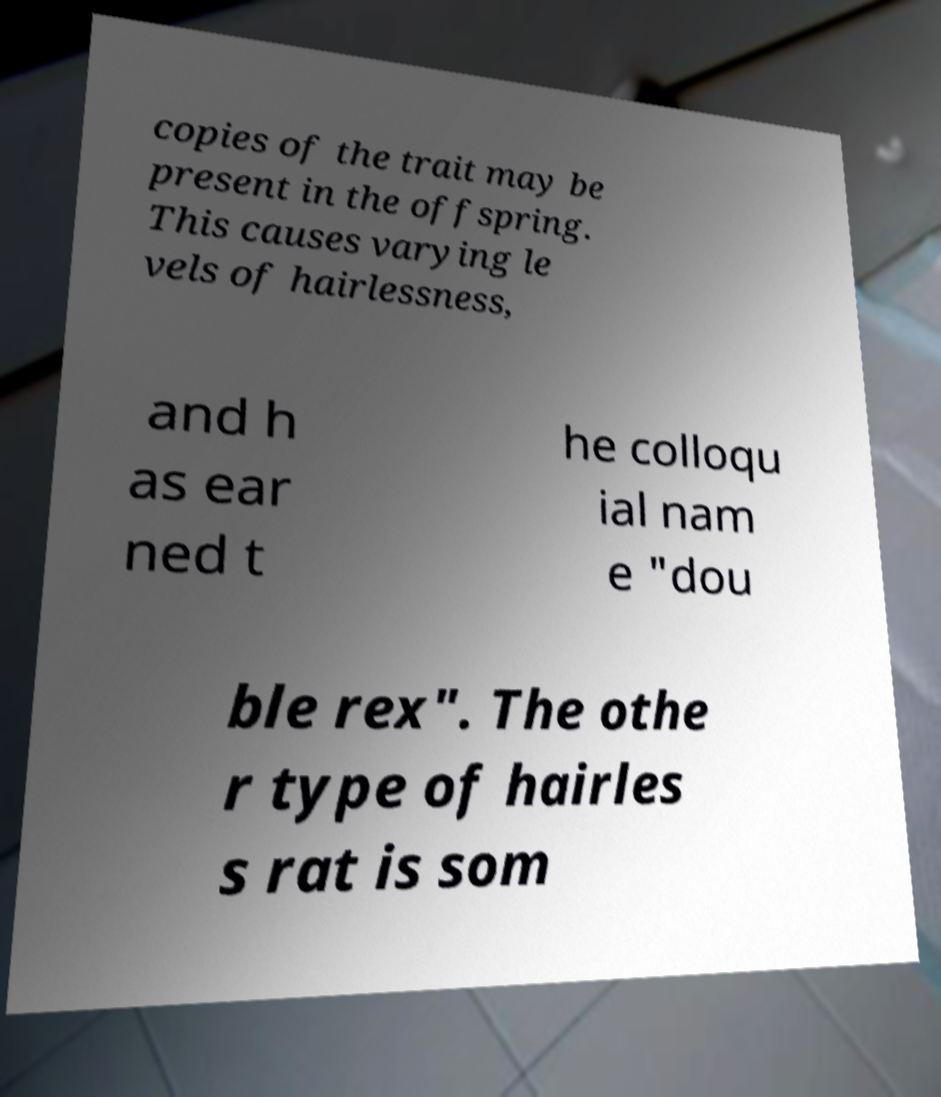What messages or text are displayed in this image? I need them in a readable, typed format. copies of the trait may be present in the offspring. This causes varying le vels of hairlessness, and h as ear ned t he colloqu ial nam e "dou ble rex". The othe r type of hairles s rat is som 